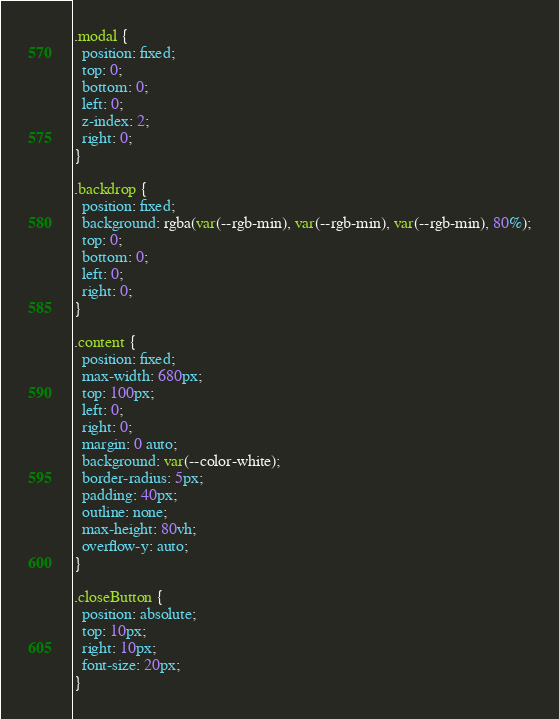Convert code to text. <code><loc_0><loc_0><loc_500><loc_500><_CSS_>.modal {
  position: fixed;
  top: 0;
  bottom: 0;
  left: 0;
  z-index: 2;
  right: 0;
}

.backdrop {
  position: fixed;
  background: rgba(var(--rgb-min), var(--rgb-min), var(--rgb-min), 80%);
  top: 0;
  bottom: 0;
  left: 0;
  right: 0;
}

.content {
  position: fixed;
  max-width: 680px;
  top: 100px;
  left: 0;
  right: 0;
  margin: 0 auto;
  background: var(--color-white);
  border-radius: 5px;
  padding: 40px;
  outline: none;
  max-height: 80vh;
  overflow-y: auto;
}

.closeButton {
  position: absolute;
  top: 10px;
  right: 10px;
  font-size: 20px;
}
</code> 